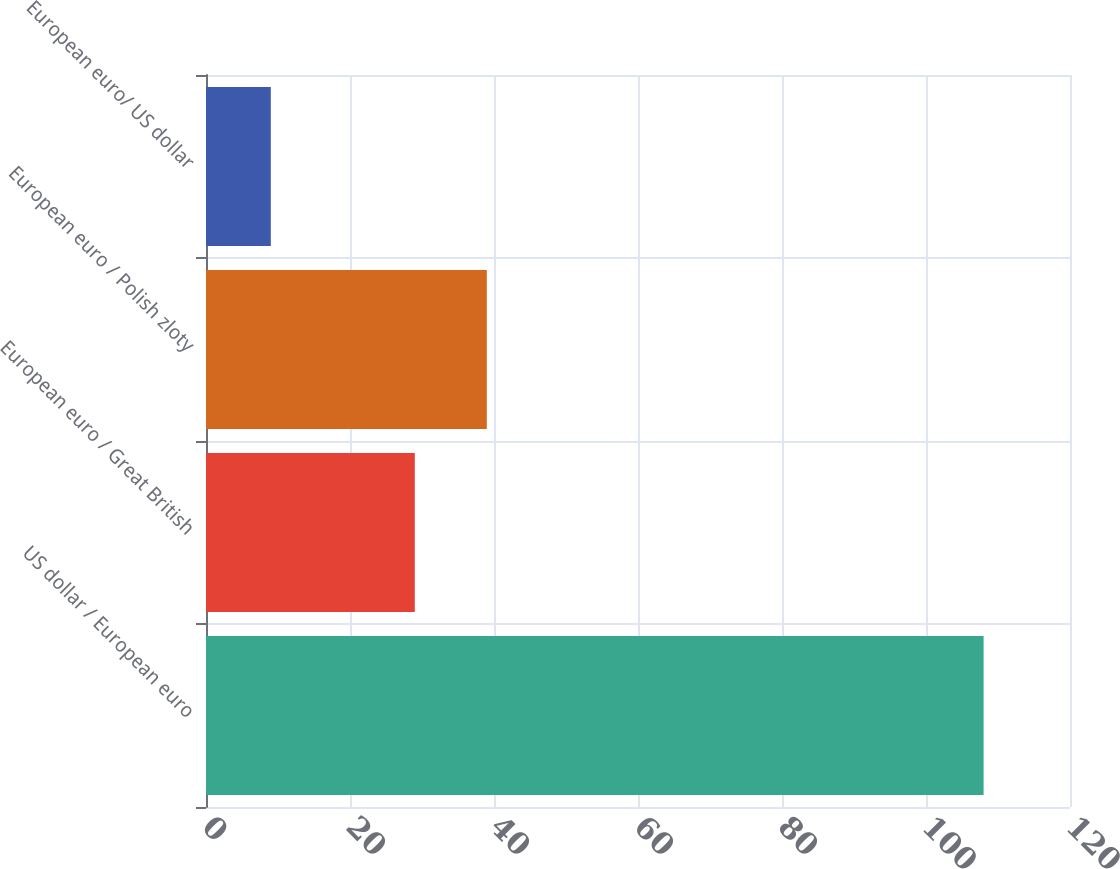Convert chart to OTSL. <chart><loc_0><loc_0><loc_500><loc_500><bar_chart><fcel>US dollar / European euro<fcel>European euro / Great British<fcel>European euro / Polish zloty<fcel>European euro/ US dollar<nl><fcel>108<fcel>29<fcel>39<fcel>9<nl></chart> 